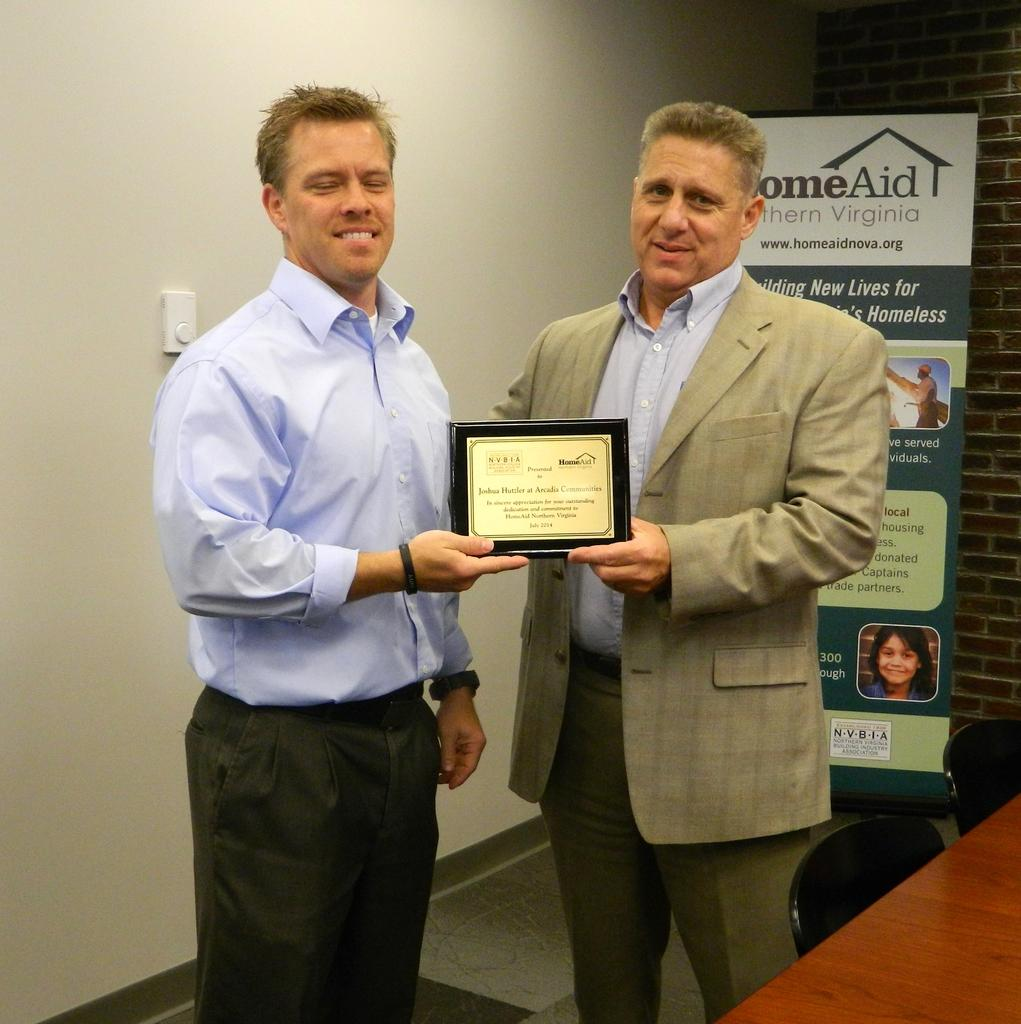What is happening between the man and the person in the image? A man is giving a certificate to a person in the image. What are the man and the person wearing? Both the man and the person are wearing blue shirts. What furniture is present in the image? There are chairs and a table in the image. What can be seen in the background of the image? There is a banner and a wall in the background. How does the man blow the coil in the image? There is no coil present in the image, and the man is not blowing anything. Are there any police officers visible in the image? There are no police officers present in the image. 